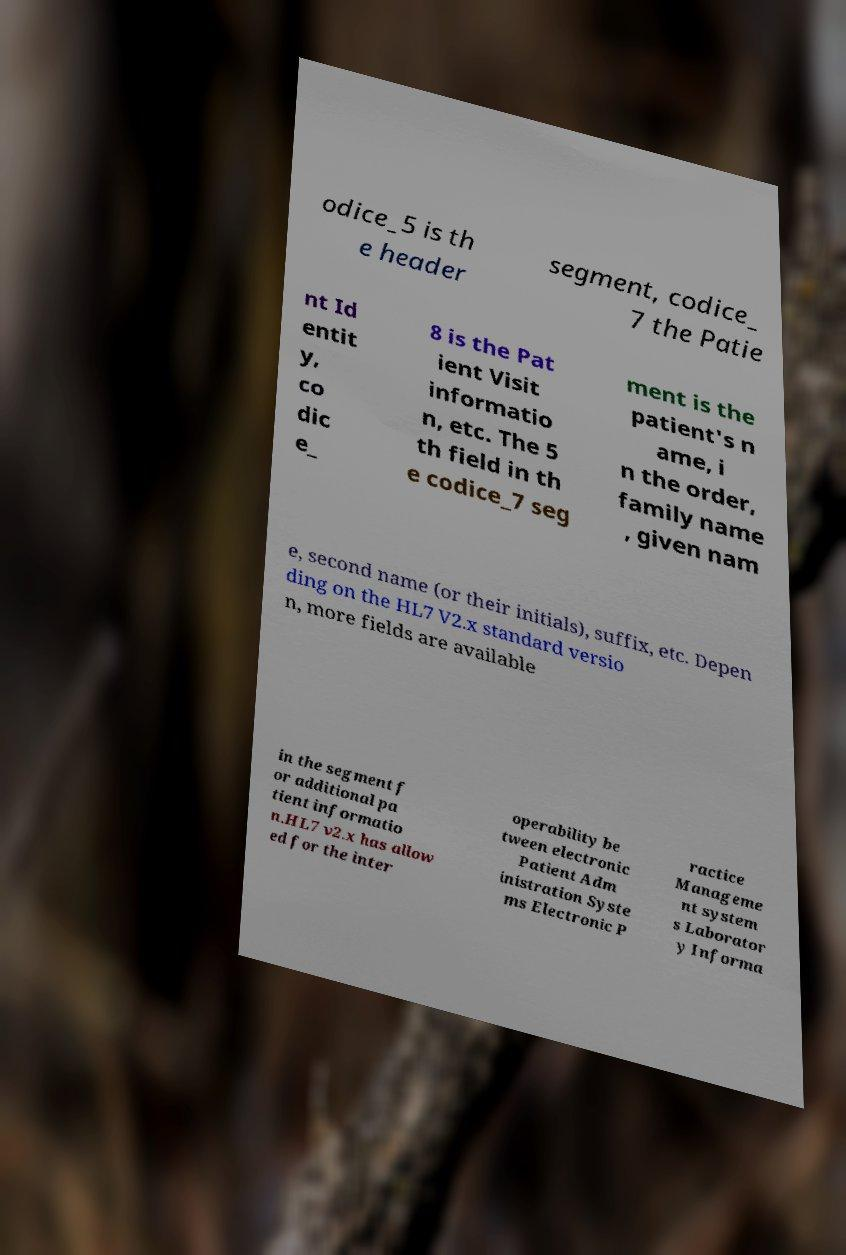Can you read and provide the text displayed in the image?This photo seems to have some interesting text. Can you extract and type it out for me? odice_5 is th e header segment, codice_ 7 the Patie nt Id entit y, co dic e_ 8 is the Pat ient Visit informatio n, etc. The 5 th field in th e codice_7 seg ment is the patient's n ame, i n the order, family name , given nam e, second name (or their initials), suffix, etc. Depen ding on the HL7 V2.x standard versio n, more fields are available in the segment f or additional pa tient informatio n.HL7 v2.x has allow ed for the inter operability be tween electronic Patient Adm inistration Syste ms Electronic P ractice Manageme nt system s Laborator y Informa 